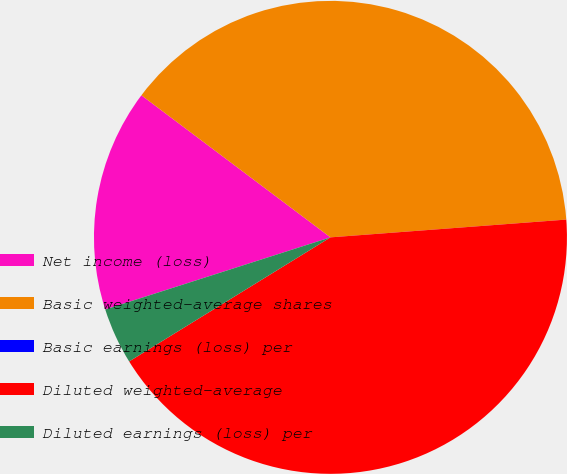<chart> <loc_0><loc_0><loc_500><loc_500><pie_chart><fcel>Net income (loss)<fcel>Basic weighted-average shares<fcel>Basic earnings (loss) per<fcel>Diluted weighted-average<fcel>Diluted earnings (loss) per<nl><fcel>15.19%<fcel>38.55%<fcel>0.0%<fcel>42.41%<fcel>3.86%<nl></chart> 